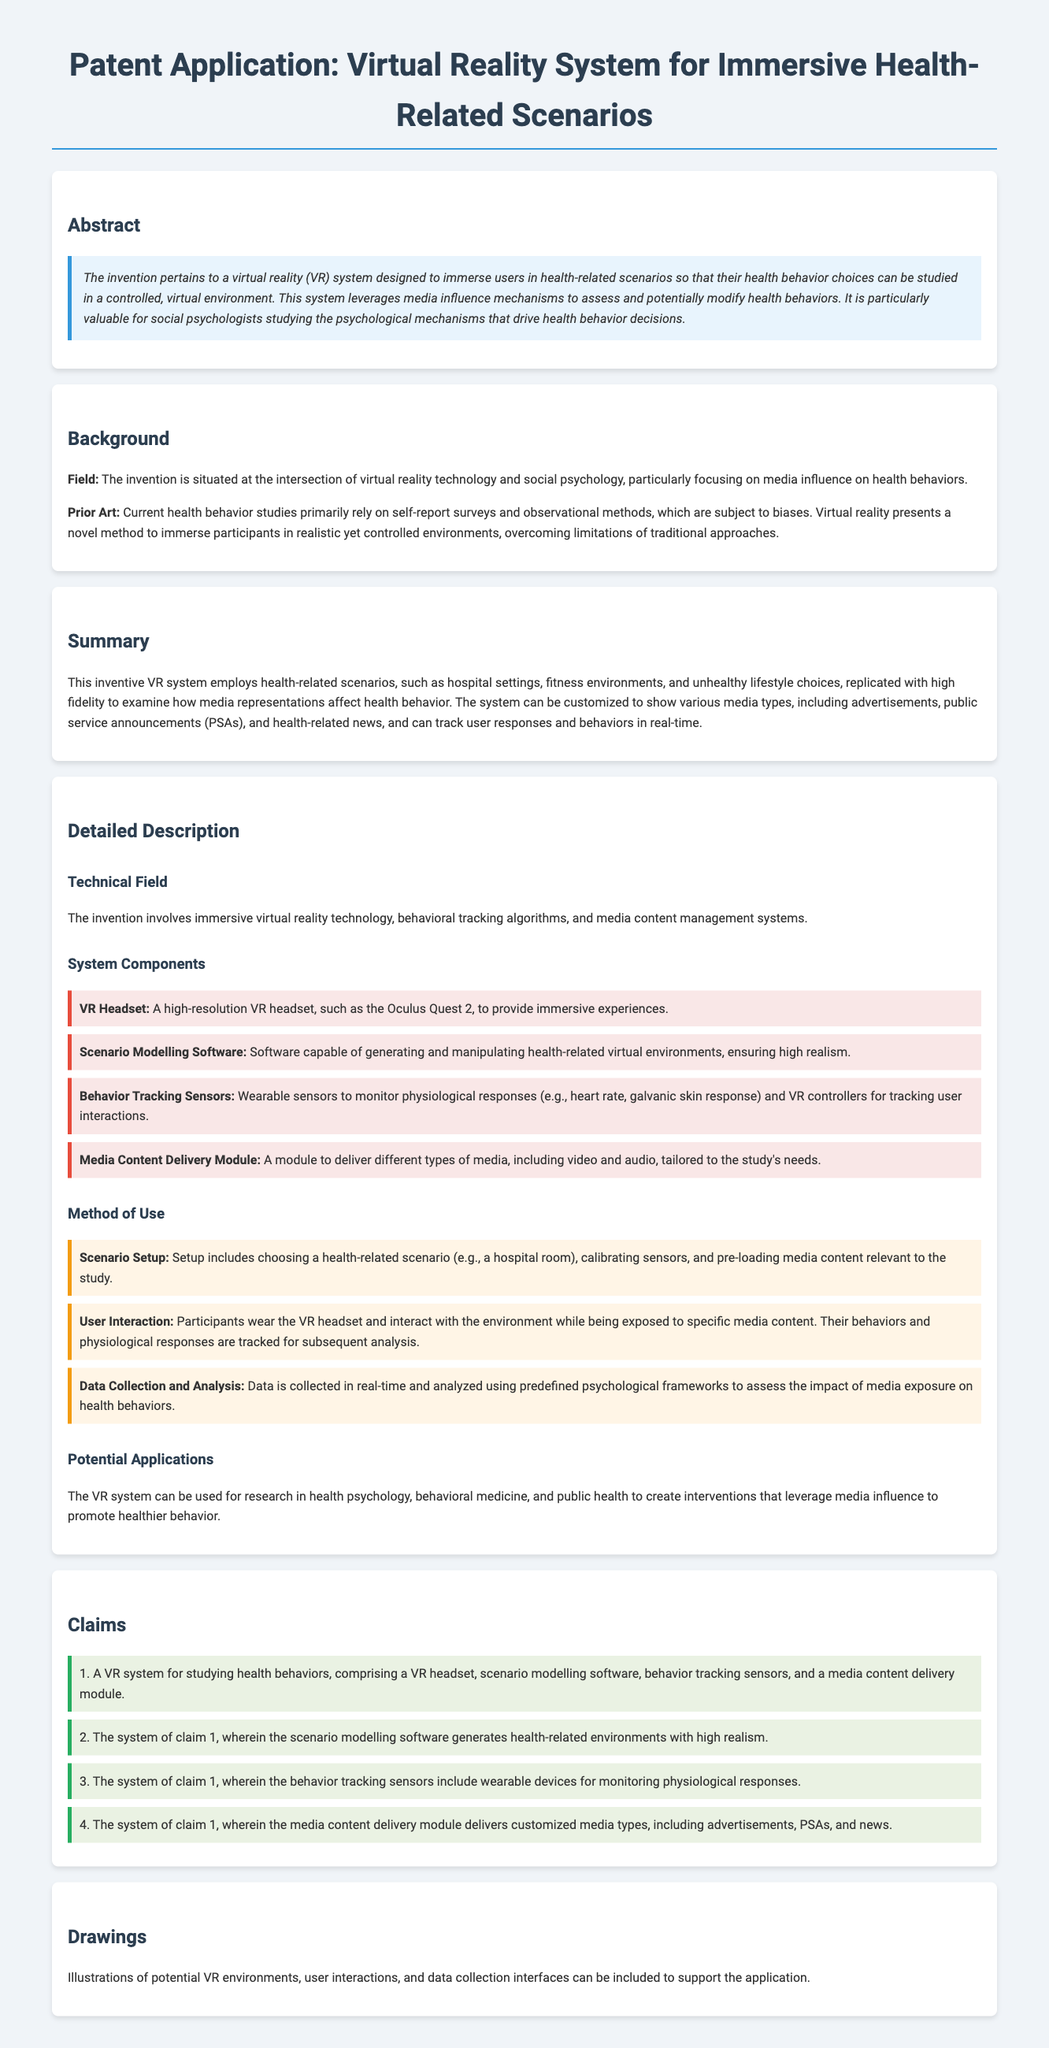What is the primary technology utilized in the invention? The primary technology utilized in the invention is virtual reality (VR) technology.
Answer: virtual reality Which component monitors physiological responses? The component that monitors physiological responses is described in the section about system components as wearable sensors.
Answer: wearable sensors What is the main purpose of the VR system? The main purpose of the VR system is to immerse users in health-related scenarios to study health behavior choices.
Answer: study health behavior choices How many claims are listed in the document? The number of claims listed in the document is four, as found in the claims section.
Answer: four What does the scenario modeling software do? The scenario modeling software generates health-related environments with high realism, as stated in the claims section.
Answer: generates health-related environments What is the potential application of the VR system mentioned? The potential application mentioned is to create interventions that leverage media influence to promote healthier behavior.
Answer: create interventions What type of media can the system deliver? The system can deliver custom media types, including advertisements, public service announcements, and health-related news.
Answer: advertisements, PSAs, and health-related news In what context is the invention situated? The invention is situated at the intersection of virtual reality technology and social psychology.
Answer: social psychology 